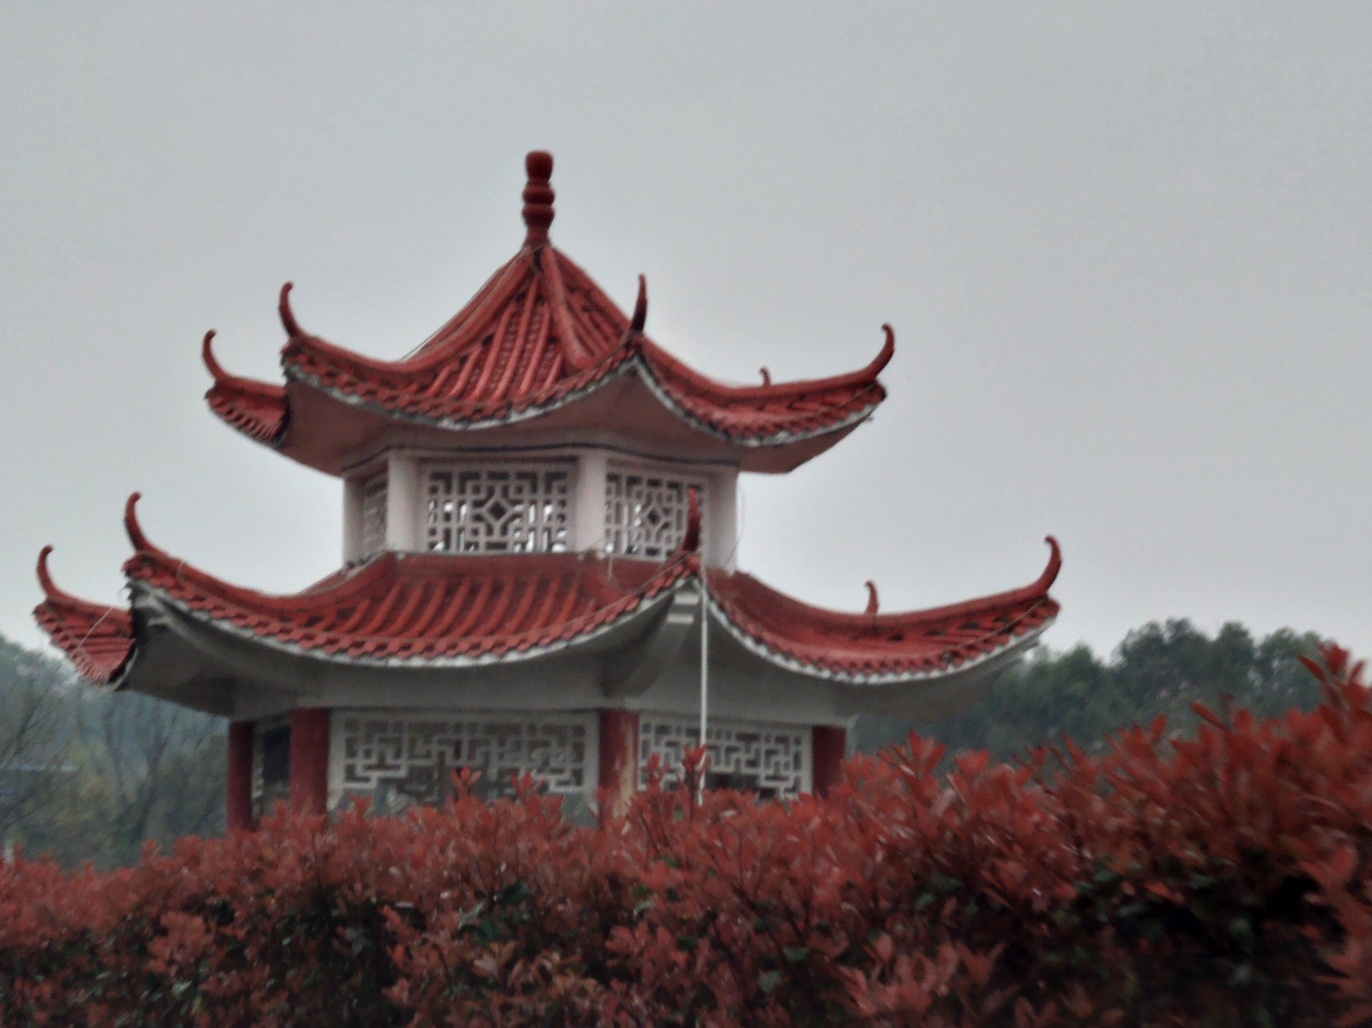What time of year do you think it is in this image? Considering the red foliage in the foreground, it could be autumn. This is when many plants change color before shedding their leaves, which matches the reddish tones seen here. 